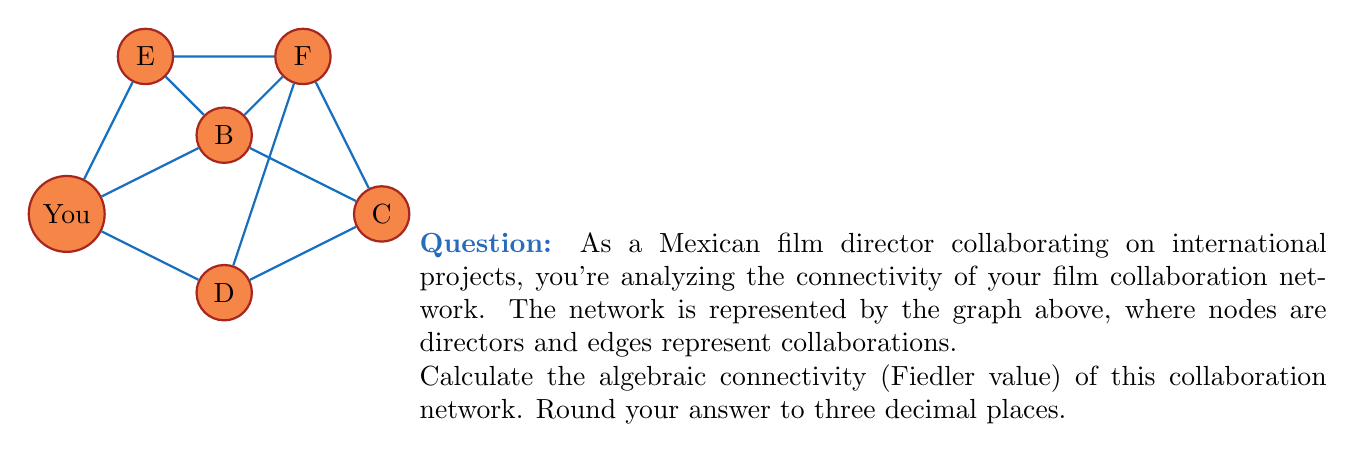Solve this math problem. To find the algebraic connectivity (Fiedler value) of the graph, we need to follow these steps:

1) First, construct the Laplacian matrix $L$ of the graph. For a graph with $n$ vertices, $L = D - A$, where $D$ is the degree matrix and $A$ is the adjacency matrix.

2) The degree matrix $D$ is:
   $$D = \begin{bmatrix}
   3 & 0 & 0 & 0 & 0 & 0 \\
   0 & 5 & 0 & 0 & 0 & 0 \\
   0 & 0 & 3 & 0 & 0 & 0 \\
   0 & 0 & 0 & 3 & 0 & 0 \\
   0 & 0 & 0 & 0 & 2 & 0 \\
   0 & 0 & 0 & 0 & 0 & 4
   \end{bmatrix}$$

3) The adjacency matrix $A$ is:
   $$A = \begin{bmatrix}
   0 & 1 & 0 & 1 & 1 & 0 \\
   1 & 0 & 1 & 0 & 1 & 1 \\
   0 & 1 & 0 & 1 & 0 & 1 \\
   1 & 0 & 1 & 0 & 0 & 1 \\
   1 & 1 & 0 & 0 & 0 & 0 \\
   0 & 1 & 1 & 1 & 0 & 0
   \end{bmatrix}$$

4) The Laplacian matrix $L = D - A$ is:
   $$L = \begin{bmatrix}
   3 & -1 & 0 & -1 & -1 & 0 \\
   -1 & 5 & -1 & 0 & -1 & -1 \\
   0 & -1 & 3 & -1 & 0 & -1 \\
   -1 & 0 & -1 & 3 & 0 & -1 \\
   -1 & -1 & 0 & 0 & 2 & 0 \\
   0 & -1 & -1 & -1 & 0 & 4
   \end{bmatrix}$$

5) Calculate the eigenvalues of $L$. The algebraic connectivity is the second smallest eigenvalue.

6) Using a mathematical software or calculator, we find the eigenvalues (rounded to 3 decimal places):
   $\lambda_1 = 0.000$
   $\lambda_2 = 0.830$
   $\lambda_3 = 2.000$
   $\lambda_4 = 3.000$
   $\lambda_5 = 4.434$
   $\lambda_6 = 5.736$

7) The second smallest eigenvalue, $\lambda_2 = 0.830$, is the algebraic connectivity (Fiedler value) of the graph.
Answer: 0.830 